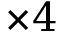Convert formula to latex. <formula><loc_0><loc_0><loc_500><loc_500>\times 4</formula> 